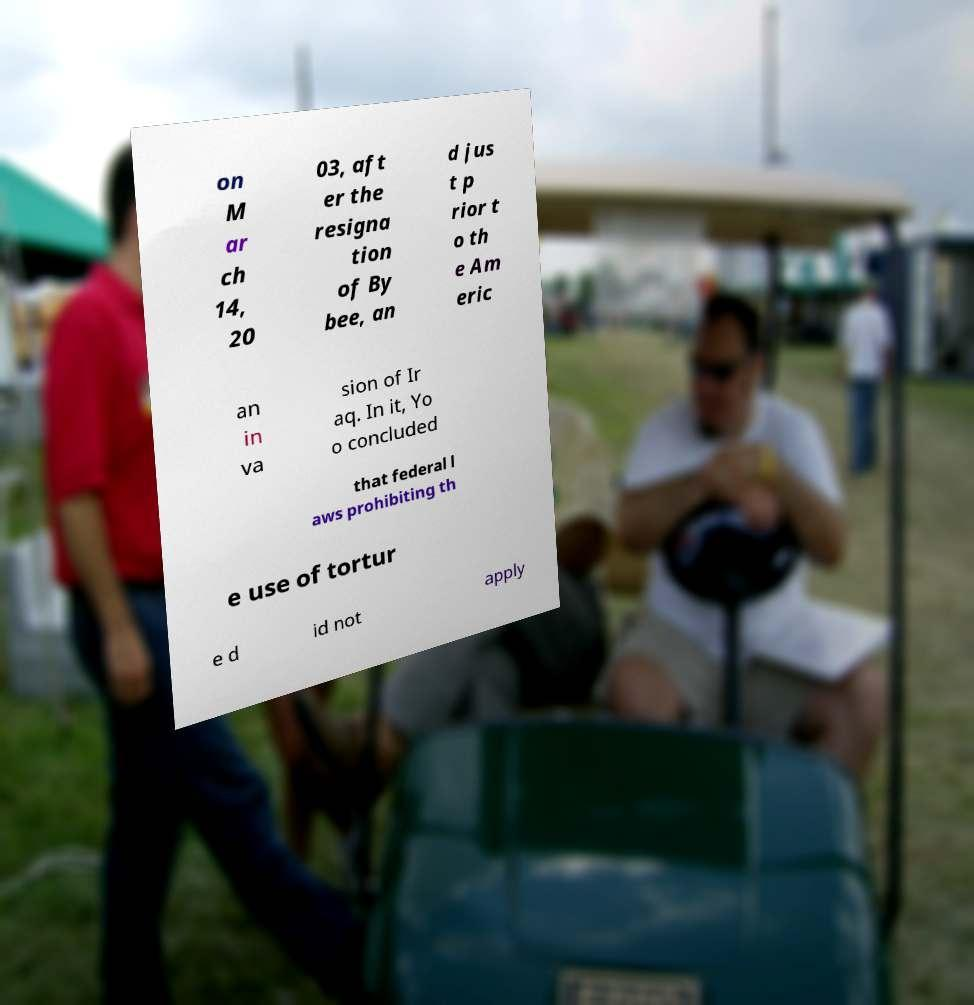What messages or text are displayed in this image? I need them in a readable, typed format. on M ar ch 14, 20 03, aft er the resigna tion of By bee, an d jus t p rior t o th e Am eric an in va sion of Ir aq. In it, Yo o concluded that federal l aws prohibiting th e use of tortur e d id not apply 